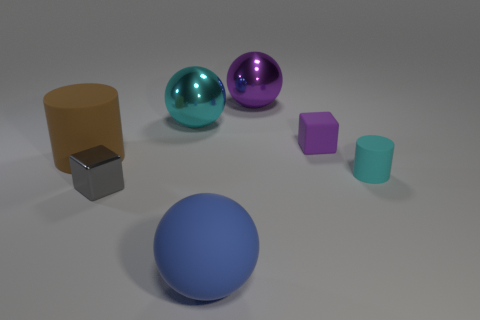Add 1 gray shiny cubes. How many objects exist? 8 Subtract all cylinders. How many objects are left? 5 Subtract 1 brown cylinders. How many objects are left? 6 Subtract all gray shiny things. Subtract all tiny metal objects. How many objects are left? 5 Add 7 large blue objects. How many large blue objects are left? 8 Add 4 large cyan metallic balls. How many large cyan metallic balls exist? 5 